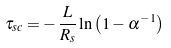<formula> <loc_0><loc_0><loc_500><loc_500>\tau _ { s c } = - \, \frac { L } { R _ { s } } \ln \left ( 1 - \alpha ^ { - 1 } \right )</formula> 